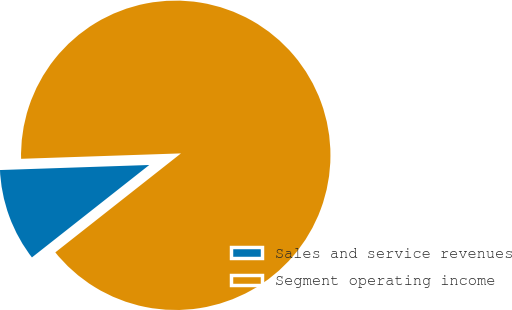Convert chart to OTSL. <chart><loc_0><loc_0><loc_500><loc_500><pie_chart><fcel>Sales and service revenues<fcel>Segment operating income<nl><fcel>10.08%<fcel>89.92%<nl></chart> 